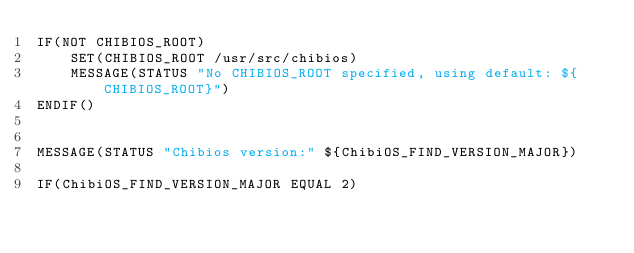<code> <loc_0><loc_0><loc_500><loc_500><_CMake_>IF(NOT CHIBIOS_ROOT)
    SET(CHIBIOS_ROOT /usr/src/chibios)
    MESSAGE(STATUS "No CHIBIOS_ROOT specified, using default: ${CHIBIOS_ROOT}")
ENDIF()


MESSAGE(STATUS "Chibios version:" ${ChibiOS_FIND_VERSION_MAJOR})

IF(ChibiOS_FIND_VERSION_MAJOR EQUAL 2)</code> 